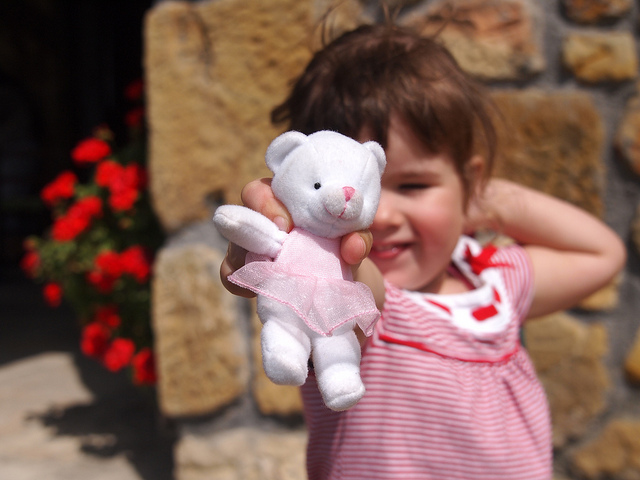<image>How old is the bear? I don't know how old the bear is. It could also be a toy. How old is the bear? It is unanswerable how old is the bear. 